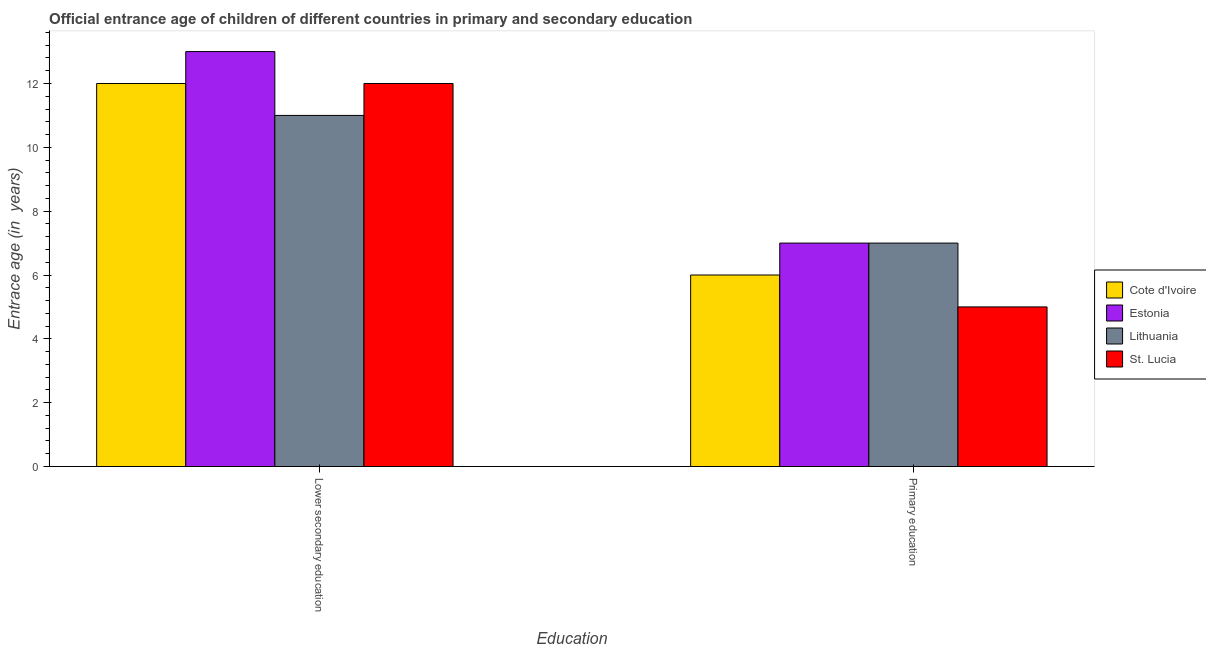How many different coloured bars are there?
Give a very brief answer. 4. How many bars are there on the 1st tick from the left?
Give a very brief answer. 4. What is the label of the 1st group of bars from the left?
Ensure brevity in your answer.  Lower secondary education. What is the entrance age of chiildren in primary education in St. Lucia?
Provide a short and direct response. 5. Across all countries, what is the maximum entrance age of children in lower secondary education?
Your answer should be compact. 13. Across all countries, what is the minimum entrance age of chiildren in primary education?
Your answer should be very brief. 5. In which country was the entrance age of children in lower secondary education maximum?
Offer a very short reply. Estonia. In which country was the entrance age of children in lower secondary education minimum?
Offer a terse response. Lithuania. What is the total entrance age of children in lower secondary education in the graph?
Ensure brevity in your answer.  48. What is the difference between the entrance age of children in lower secondary education in Estonia and that in St. Lucia?
Make the answer very short. 1. What is the difference between the entrance age of children in lower secondary education in Lithuania and the entrance age of chiildren in primary education in St. Lucia?
Ensure brevity in your answer.  6. What is the average entrance age of children in lower secondary education per country?
Provide a short and direct response. 12. What is the difference between the entrance age of children in lower secondary education and entrance age of chiildren in primary education in Lithuania?
Your answer should be compact. 4. In how many countries, is the entrance age of chiildren in primary education greater than 7.2 years?
Offer a terse response. 0. What is the ratio of the entrance age of chiildren in primary education in Cote d'Ivoire to that in Estonia?
Give a very brief answer. 0.86. In how many countries, is the entrance age of children in lower secondary education greater than the average entrance age of children in lower secondary education taken over all countries?
Your response must be concise. 1. What does the 1st bar from the left in Primary education represents?
Provide a succinct answer. Cote d'Ivoire. What does the 3rd bar from the right in Primary education represents?
Offer a very short reply. Estonia. Are all the bars in the graph horizontal?
Offer a terse response. No. Are the values on the major ticks of Y-axis written in scientific E-notation?
Provide a succinct answer. No. Does the graph contain grids?
Provide a succinct answer. No. What is the title of the graph?
Keep it short and to the point. Official entrance age of children of different countries in primary and secondary education. Does "Albania" appear as one of the legend labels in the graph?
Provide a short and direct response. No. What is the label or title of the X-axis?
Your answer should be compact. Education. What is the label or title of the Y-axis?
Your answer should be compact. Entrace age (in  years). What is the Entrace age (in  years) in Estonia in Lower secondary education?
Offer a terse response. 13. What is the Entrace age (in  years) of Lithuania in Lower secondary education?
Offer a very short reply. 11. What is the Entrace age (in  years) in St. Lucia in Lower secondary education?
Keep it short and to the point. 12. What is the Entrace age (in  years) of Cote d'Ivoire in Primary education?
Your response must be concise. 6. What is the Entrace age (in  years) of St. Lucia in Primary education?
Provide a succinct answer. 5. Across all Education, what is the maximum Entrace age (in  years) of Cote d'Ivoire?
Give a very brief answer. 12. Across all Education, what is the maximum Entrace age (in  years) of Estonia?
Keep it short and to the point. 13. Across all Education, what is the maximum Entrace age (in  years) in St. Lucia?
Offer a very short reply. 12. Across all Education, what is the minimum Entrace age (in  years) in Estonia?
Keep it short and to the point. 7. Across all Education, what is the minimum Entrace age (in  years) of St. Lucia?
Your answer should be compact. 5. What is the total Entrace age (in  years) of Estonia in the graph?
Your answer should be very brief. 20. What is the difference between the Entrace age (in  years) of Cote d'Ivoire in Lower secondary education and that in Primary education?
Give a very brief answer. 6. What is the difference between the Entrace age (in  years) in Lithuania in Lower secondary education and that in Primary education?
Offer a very short reply. 4. What is the difference between the Entrace age (in  years) of St. Lucia in Lower secondary education and that in Primary education?
Offer a very short reply. 7. What is the difference between the Entrace age (in  years) of Cote d'Ivoire in Lower secondary education and the Entrace age (in  years) of Lithuania in Primary education?
Make the answer very short. 5. What is the difference between the Entrace age (in  years) of Estonia in Lower secondary education and the Entrace age (in  years) of Lithuania in Primary education?
Your answer should be very brief. 6. What is the average Entrace age (in  years) of Cote d'Ivoire per Education?
Keep it short and to the point. 9. What is the difference between the Entrace age (in  years) in Estonia and Entrace age (in  years) in St. Lucia in Lower secondary education?
Keep it short and to the point. 1. What is the difference between the Entrace age (in  years) of Cote d'Ivoire and Entrace age (in  years) of Lithuania in Primary education?
Make the answer very short. -1. What is the difference between the Entrace age (in  years) of Estonia and Entrace age (in  years) of Lithuania in Primary education?
Ensure brevity in your answer.  0. What is the difference between the Entrace age (in  years) in Estonia and Entrace age (in  years) in St. Lucia in Primary education?
Offer a very short reply. 2. What is the difference between the Entrace age (in  years) in Lithuania and Entrace age (in  years) in St. Lucia in Primary education?
Offer a terse response. 2. What is the ratio of the Entrace age (in  years) in Cote d'Ivoire in Lower secondary education to that in Primary education?
Ensure brevity in your answer.  2. What is the ratio of the Entrace age (in  years) in Estonia in Lower secondary education to that in Primary education?
Offer a terse response. 1.86. What is the ratio of the Entrace age (in  years) in Lithuania in Lower secondary education to that in Primary education?
Keep it short and to the point. 1.57. What is the ratio of the Entrace age (in  years) in St. Lucia in Lower secondary education to that in Primary education?
Offer a terse response. 2.4. What is the difference between the highest and the second highest Entrace age (in  years) of Cote d'Ivoire?
Your answer should be very brief. 6. What is the difference between the highest and the second highest Entrace age (in  years) in Estonia?
Ensure brevity in your answer.  6. What is the difference between the highest and the second highest Entrace age (in  years) in Lithuania?
Keep it short and to the point. 4. What is the difference between the highest and the second highest Entrace age (in  years) of St. Lucia?
Offer a terse response. 7. What is the difference between the highest and the lowest Entrace age (in  years) of Cote d'Ivoire?
Ensure brevity in your answer.  6. What is the difference between the highest and the lowest Entrace age (in  years) in Estonia?
Provide a succinct answer. 6. 